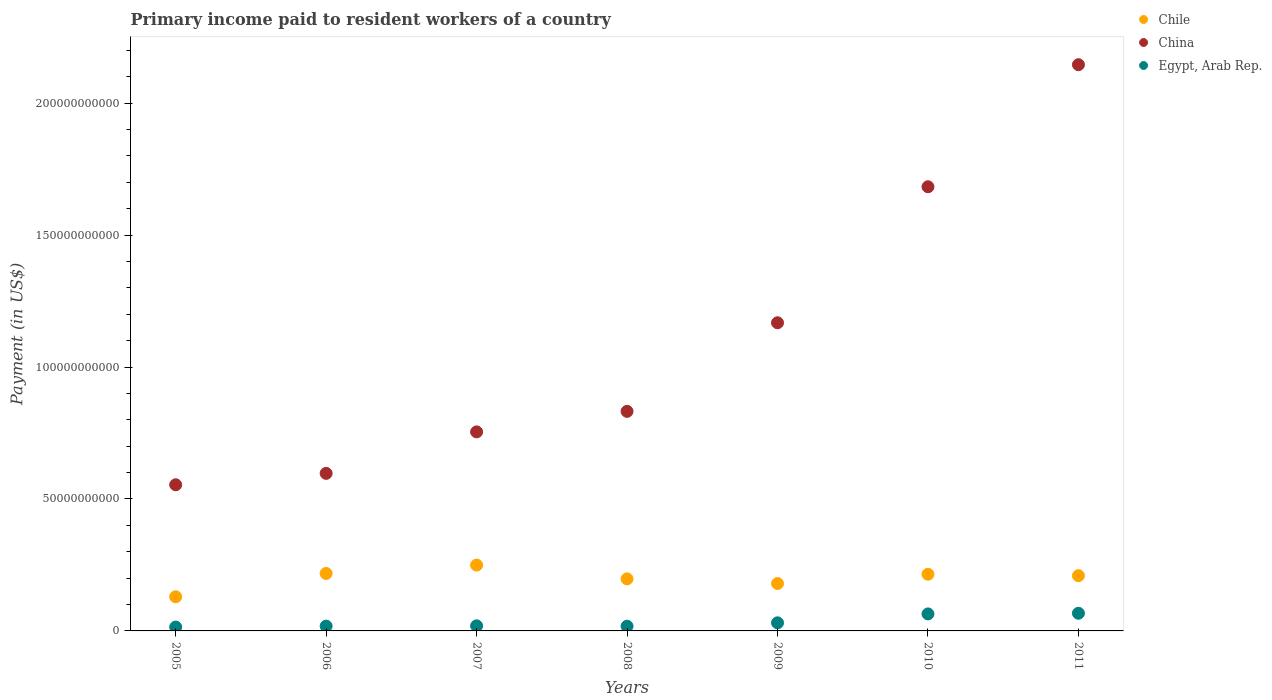Is the number of dotlines equal to the number of legend labels?
Offer a terse response. Yes. What is the amount paid to workers in Chile in 2006?
Keep it short and to the point. 2.18e+1. Across all years, what is the maximum amount paid to workers in Chile?
Provide a short and direct response. 2.49e+1. Across all years, what is the minimum amount paid to workers in China?
Your answer should be very brief. 5.54e+1. What is the total amount paid to workers in China in the graph?
Provide a succinct answer. 7.73e+11. What is the difference between the amount paid to workers in Egypt, Arab Rep. in 2005 and that in 2010?
Provide a succinct answer. -4.99e+09. What is the difference between the amount paid to workers in Egypt, Arab Rep. in 2009 and the amount paid to workers in Chile in 2007?
Keep it short and to the point. -2.19e+1. What is the average amount paid to workers in Chile per year?
Your answer should be compact. 2.00e+1. In the year 2008, what is the difference between the amount paid to workers in Chile and amount paid to workers in China?
Keep it short and to the point. -6.35e+1. In how many years, is the amount paid to workers in China greater than 150000000000 US$?
Offer a very short reply. 2. What is the ratio of the amount paid to workers in China in 2007 to that in 2010?
Your answer should be very brief. 0.45. Is the difference between the amount paid to workers in Chile in 2009 and 2010 greater than the difference between the amount paid to workers in China in 2009 and 2010?
Provide a short and direct response. Yes. What is the difference between the highest and the second highest amount paid to workers in Chile?
Your answer should be compact. 3.17e+09. What is the difference between the highest and the lowest amount paid to workers in Chile?
Your response must be concise. 1.20e+1. In how many years, is the amount paid to workers in China greater than the average amount paid to workers in China taken over all years?
Provide a short and direct response. 3. Is the sum of the amount paid to workers in Chile in 2008 and 2009 greater than the maximum amount paid to workers in Egypt, Arab Rep. across all years?
Your answer should be compact. Yes. What is the difference between two consecutive major ticks on the Y-axis?
Offer a terse response. 5.00e+1. Does the graph contain any zero values?
Provide a succinct answer. No. Where does the legend appear in the graph?
Your response must be concise. Top right. How many legend labels are there?
Provide a short and direct response. 3. How are the legend labels stacked?
Give a very brief answer. Vertical. What is the title of the graph?
Your answer should be very brief. Primary income paid to resident workers of a country. Does "Europe(all income levels)" appear as one of the legend labels in the graph?
Your answer should be compact. No. What is the label or title of the Y-axis?
Offer a terse response. Payment (in US$). What is the Payment (in US$) of Chile in 2005?
Provide a short and direct response. 1.29e+1. What is the Payment (in US$) in China in 2005?
Your answer should be compact. 5.54e+1. What is the Payment (in US$) of Egypt, Arab Rep. in 2005?
Ensure brevity in your answer.  1.46e+09. What is the Payment (in US$) of Chile in 2006?
Your answer should be compact. 2.18e+1. What is the Payment (in US$) of China in 2006?
Your answer should be very brief. 5.97e+1. What is the Payment (in US$) in Egypt, Arab Rep. in 2006?
Keep it short and to the point. 1.82e+09. What is the Payment (in US$) in Chile in 2007?
Your answer should be compact. 2.49e+1. What is the Payment (in US$) in China in 2007?
Provide a short and direct response. 7.54e+1. What is the Payment (in US$) in Egypt, Arab Rep. in 2007?
Provide a succinct answer. 1.92e+09. What is the Payment (in US$) in Chile in 2008?
Provide a succinct answer. 1.97e+1. What is the Payment (in US$) in China in 2008?
Your answer should be very brief. 8.32e+1. What is the Payment (in US$) of Egypt, Arab Rep. in 2008?
Your answer should be very brief. 1.78e+09. What is the Payment (in US$) in Chile in 2009?
Keep it short and to the point. 1.80e+1. What is the Payment (in US$) in China in 2009?
Make the answer very short. 1.17e+11. What is the Payment (in US$) of Egypt, Arab Rep. in 2009?
Provide a short and direct response. 3.07e+09. What is the Payment (in US$) in Chile in 2010?
Give a very brief answer. 2.15e+1. What is the Payment (in US$) of China in 2010?
Your answer should be compact. 1.68e+11. What is the Payment (in US$) in Egypt, Arab Rep. in 2010?
Provide a succinct answer. 6.45e+09. What is the Payment (in US$) in Chile in 2011?
Keep it short and to the point. 2.09e+1. What is the Payment (in US$) in China in 2011?
Offer a terse response. 2.15e+11. What is the Payment (in US$) of Egypt, Arab Rep. in 2011?
Keep it short and to the point. 6.69e+09. Across all years, what is the maximum Payment (in US$) in Chile?
Keep it short and to the point. 2.49e+1. Across all years, what is the maximum Payment (in US$) in China?
Offer a terse response. 2.15e+11. Across all years, what is the maximum Payment (in US$) in Egypt, Arab Rep.?
Provide a succinct answer. 6.69e+09. Across all years, what is the minimum Payment (in US$) of Chile?
Provide a short and direct response. 1.29e+1. Across all years, what is the minimum Payment (in US$) in China?
Your answer should be compact. 5.54e+1. Across all years, what is the minimum Payment (in US$) in Egypt, Arab Rep.?
Provide a succinct answer. 1.46e+09. What is the total Payment (in US$) in Chile in the graph?
Provide a succinct answer. 1.40e+11. What is the total Payment (in US$) of China in the graph?
Provide a succinct answer. 7.73e+11. What is the total Payment (in US$) in Egypt, Arab Rep. in the graph?
Your answer should be very brief. 2.32e+1. What is the difference between the Payment (in US$) in Chile in 2005 and that in 2006?
Your answer should be very brief. -8.84e+09. What is the difference between the Payment (in US$) of China in 2005 and that in 2006?
Offer a terse response. -4.32e+09. What is the difference between the Payment (in US$) in Egypt, Arab Rep. in 2005 and that in 2006?
Offer a very short reply. -3.62e+08. What is the difference between the Payment (in US$) in Chile in 2005 and that in 2007?
Make the answer very short. -1.20e+1. What is the difference between the Payment (in US$) in China in 2005 and that in 2007?
Provide a succinct answer. -2.00e+1. What is the difference between the Payment (in US$) in Egypt, Arab Rep. in 2005 and that in 2007?
Provide a short and direct response. -4.61e+08. What is the difference between the Payment (in US$) of Chile in 2005 and that in 2008?
Your answer should be very brief. -6.79e+09. What is the difference between the Payment (in US$) of China in 2005 and that in 2008?
Provide a succinct answer. -2.78e+1. What is the difference between the Payment (in US$) of Egypt, Arab Rep. in 2005 and that in 2008?
Make the answer very short. -3.16e+08. What is the difference between the Payment (in US$) of Chile in 2005 and that in 2009?
Offer a terse response. -5.03e+09. What is the difference between the Payment (in US$) in China in 2005 and that in 2009?
Your answer should be very brief. -6.14e+1. What is the difference between the Payment (in US$) of Egypt, Arab Rep. in 2005 and that in 2009?
Provide a succinct answer. -1.61e+09. What is the difference between the Payment (in US$) in Chile in 2005 and that in 2010?
Keep it short and to the point. -8.54e+09. What is the difference between the Payment (in US$) in China in 2005 and that in 2010?
Ensure brevity in your answer.  -1.13e+11. What is the difference between the Payment (in US$) of Egypt, Arab Rep. in 2005 and that in 2010?
Your answer should be very brief. -4.99e+09. What is the difference between the Payment (in US$) in Chile in 2005 and that in 2011?
Provide a succinct answer. -7.99e+09. What is the difference between the Payment (in US$) in China in 2005 and that in 2011?
Give a very brief answer. -1.59e+11. What is the difference between the Payment (in US$) in Egypt, Arab Rep. in 2005 and that in 2011?
Offer a terse response. -5.23e+09. What is the difference between the Payment (in US$) of Chile in 2006 and that in 2007?
Your response must be concise. -3.17e+09. What is the difference between the Payment (in US$) in China in 2006 and that in 2007?
Provide a succinct answer. -1.57e+1. What is the difference between the Payment (in US$) in Egypt, Arab Rep. in 2006 and that in 2007?
Offer a very short reply. -9.87e+07. What is the difference between the Payment (in US$) of Chile in 2006 and that in 2008?
Give a very brief answer. 2.05e+09. What is the difference between the Payment (in US$) of China in 2006 and that in 2008?
Your answer should be compact. -2.35e+1. What is the difference between the Payment (in US$) in Egypt, Arab Rep. in 2006 and that in 2008?
Your answer should be very brief. 4.58e+07. What is the difference between the Payment (in US$) of Chile in 2006 and that in 2009?
Your answer should be compact. 3.81e+09. What is the difference between the Payment (in US$) of China in 2006 and that in 2009?
Your response must be concise. -5.71e+1. What is the difference between the Payment (in US$) in Egypt, Arab Rep. in 2006 and that in 2009?
Your response must be concise. -1.25e+09. What is the difference between the Payment (in US$) of Chile in 2006 and that in 2010?
Keep it short and to the point. 2.93e+08. What is the difference between the Payment (in US$) of China in 2006 and that in 2010?
Offer a terse response. -1.09e+11. What is the difference between the Payment (in US$) in Egypt, Arab Rep. in 2006 and that in 2010?
Offer a very short reply. -4.62e+09. What is the difference between the Payment (in US$) in Chile in 2006 and that in 2011?
Provide a short and direct response. 8.47e+08. What is the difference between the Payment (in US$) in China in 2006 and that in 2011?
Ensure brevity in your answer.  -1.55e+11. What is the difference between the Payment (in US$) of Egypt, Arab Rep. in 2006 and that in 2011?
Keep it short and to the point. -4.87e+09. What is the difference between the Payment (in US$) of Chile in 2007 and that in 2008?
Make the answer very short. 5.22e+09. What is the difference between the Payment (in US$) of China in 2007 and that in 2008?
Keep it short and to the point. -7.78e+09. What is the difference between the Payment (in US$) in Egypt, Arab Rep. in 2007 and that in 2008?
Keep it short and to the point. 1.44e+08. What is the difference between the Payment (in US$) in Chile in 2007 and that in 2009?
Your response must be concise. 6.98e+09. What is the difference between the Payment (in US$) of China in 2007 and that in 2009?
Offer a very short reply. -4.14e+1. What is the difference between the Payment (in US$) in Egypt, Arab Rep. in 2007 and that in 2009?
Offer a very short reply. -1.15e+09. What is the difference between the Payment (in US$) in Chile in 2007 and that in 2010?
Provide a succinct answer. 3.47e+09. What is the difference between the Payment (in US$) in China in 2007 and that in 2010?
Offer a terse response. -9.29e+1. What is the difference between the Payment (in US$) of Egypt, Arab Rep. in 2007 and that in 2010?
Your answer should be very brief. -4.52e+09. What is the difference between the Payment (in US$) in Chile in 2007 and that in 2011?
Offer a terse response. 4.02e+09. What is the difference between the Payment (in US$) of China in 2007 and that in 2011?
Your answer should be very brief. -1.39e+11. What is the difference between the Payment (in US$) of Egypt, Arab Rep. in 2007 and that in 2011?
Your answer should be very brief. -4.77e+09. What is the difference between the Payment (in US$) in Chile in 2008 and that in 2009?
Give a very brief answer. 1.76e+09. What is the difference between the Payment (in US$) in China in 2008 and that in 2009?
Make the answer very short. -3.36e+1. What is the difference between the Payment (in US$) in Egypt, Arab Rep. in 2008 and that in 2009?
Offer a terse response. -1.29e+09. What is the difference between the Payment (in US$) in Chile in 2008 and that in 2010?
Ensure brevity in your answer.  -1.75e+09. What is the difference between the Payment (in US$) of China in 2008 and that in 2010?
Keep it short and to the point. -8.51e+1. What is the difference between the Payment (in US$) of Egypt, Arab Rep. in 2008 and that in 2010?
Your answer should be compact. -4.67e+09. What is the difference between the Payment (in US$) of Chile in 2008 and that in 2011?
Provide a short and direct response. -1.20e+09. What is the difference between the Payment (in US$) of China in 2008 and that in 2011?
Keep it short and to the point. -1.31e+11. What is the difference between the Payment (in US$) of Egypt, Arab Rep. in 2008 and that in 2011?
Provide a short and direct response. -4.92e+09. What is the difference between the Payment (in US$) in Chile in 2009 and that in 2010?
Keep it short and to the point. -3.52e+09. What is the difference between the Payment (in US$) of China in 2009 and that in 2010?
Keep it short and to the point. -5.15e+1. What is the difference between the Payment (in US$) of Egypt, Arab Rep. in 2009 and that in 2010?
Provide a succinct answer. -3.38e+09. What is the difference between the Payment (in US$) of Chile in 2009 and that in 2011?
Make the answer very short. -2.96e+09. What is the difference between the Payment (in US$) of China in 2009 and that in 2011?
Your response must be concise. -9.78e+1. What is the difference between the Payment (in US$) of Egypt, Arab Rep. in 2009 and that in 2011?
Provide a short and direct response. -3.63e+09. What is the difference between the Payment (in US$) in Chile in 2010 and that in 2011?
Offer a terse response. 5.54e+08. What is the difference between the Payment (in US$) in China in 2010 and that in 2011?
Make the answer very short. -4.63e+1. What is the difference between the Payment (in US$) of Egypt, Arab Rep. in 2010 and that in 2011?
Offer a very short reply. -2.49e+08. What is the difference between the Payment (in US$) of Chile in 2005 and the Payment (in US$) of China in 2006?
Offer a very short reply. -4.68e+1. What is the difference between the Payment (in US$) in Chile in 2005 and the Payment (in US$) in Egypt, Arab Rep. in 2006?
Your answer should be compact. 1.11e+1. What is the difference between the Payment (in US$) in China in 2005 and the Payment (in US$) in Egypt, Arab Rep. in 2006?
Ensure brevity in your answer.  5.36e+1. What is the difference between the Payment (in US$) of Chile in 2005 and the Payment (in US$) of China in 2007?
Offer a very short reply. -6.25e+1. What is the difference between the Payment (in US$) in Chile in 2005 and the Payment (in US$) in Egypt, Arab Rep. in 2007?
Provide a succinct answer. 1.10e+1. What is the difference between the Payment (in US$) in China in 2005 and the Payment (in US$) in Egypt, Arab Rep. in 2007?
Keep it short and to the point. 5.35e+1. What is the difference between the Payment (in US$) in Chile in 2005 and the Payment (in US$) in China in 2008?
Your response must be concise. -7.03e+1. What is the difference between the Payment (in US$) in Chile in 2005 and the Payment (in US$) in Egypt, Arab Rep. in 2008?
Provide a succinct answer. 1.12e+1. What is the difference between the Payment (in US$) of China in 2005 and the Payment (in US$) of Egypt, Arab Rep. in 2008?
Keep it short and to the point. 5.36e+1. What is the difference between the Payment (in US$) in Chile in 2005 and the Payment (in US$) in China in 2009?
Offer a terse response. -1.04e+11. What is the difference between the Payment (in US$) in Chile in 2005 and the Payment (in US$) in Egypt, Arab Rep. in 2009?
Your response must be concise. 9.87e+09. What is the difference between the Payment (in US$) in China in 2005 and the Payment (in US$) in Egypt, Arab Rep. in 2009?
Provide a short and direct response. 5.23e+1. What is the difference between the Payment (in US$) in Chile in 2005 and the Payment (in US$) in China in 2010?
Give a very brief answer. -1.55e+11. What is the difference between the Payment (in US$) of Chile in 2005 and the Payment (in US$) of Egypt, Arab Rep. in 2010?
Provide a succinct answer. 6.49e+09. What is the difference between the Payment (in US$) in China in 2005 and the Payment (in US$) in Egypt, Arab Rep. in 2010?
Ensure brevity in your answer.  4.89e+1. What is the difference between the Payment (in US$) of Chile in 2005 and the Payment (in US$) of China in 2011?
Your answer should be very brief. -2.02e+11. What is the difference between the Payment (in US$) in Chile in 2005 and the Payment (in US$) in Egypt, Arab Rep. in 2011?
Ensure brevity in your answer.  6.24e+09. What is the difference between the Payment (in US$) in China in 2005 and the Payment (in US$) in Egypt, Arab Rep. in 2011?
Your response must be concise. 4.87e+1. What is the difference between the Payment (in US$) of Chile in 2006 and the Payment (in US$) of China in 2007?
Your answer should be very brief. -5.37e+1. What is the difference between the Payment (in US$) in Chile in 2006 and the Payment (in US$) in Egypt, Arab Rep. in 2007?
Your response must be concise. 1.99e+1. What is the difference between the Payment (in US$) in China in 2006 and the Payment (in US$) in Egypt, Arab Rep. in 2007?
Your answer should be compact. 5.78e+1. What is the difference between the Payment (in US$) in Chile in 2006 and the Payment (in US$) in China in 2008?
Your answer should be very brief. -6.14e+1. What is the difference between the Payment (in US$) of Chile in 2006 and the Payment (in US$) of Egypt, Arab Rep. in 2008?
Your answer should be compact. 2.00e+1. What is the difference between the Payment (in US$) of China in 2006 and the Payment (in US$) of Egypt, Arab Rep. in 2008?
Keep it short and to the point. 5.79e+1. What is the difference between the Payment (in US$) of Chile in 2006 and the Payment (in US$) of China in 2009?
Ensure brevity in your answer.  -9.50e+1. What is the difference between the Payment (in US$) of Chile in 2006 and the Payment (in US$) of Egypt, Arab Rep. in 2009?
Offer a terse response. 1.87e+1. What is the difference between the Payment (in US$) of China in 2006 and the Payment (in US$) of Egypt, Arab Rep. in 2009?
Provide a succinct answer. 5.66e+1. What is the difference between the Payment (in US$) in Chile in 2006 and the Payment (in US$) in China in 2010?
Make the answer very short. -1.47e+11. What is the difference between the Payment (in US$) in Chile in 2006 and the Payment (in US$) in Egypt, Arab Rep. in 2010?
Make the answer very short. 1.53e+1. What is the difference between the Payment (in US$) in China in 2006 and the Payment (in US$) in Egypt, Arab Rep. in 2010?
Offer a very short reply. 5.33e+1. What is the difference between the Payment (in US$) in Chile in 2006 and the Payment (in US$) in China in 2011?
Provide a succinct answer. -1.93e+11. What is the difference between the Payment (in US$) in Chile in 2006 and the Payment (in US$) in Egypt, Arab Rep. in 2011?
Give a very brief answer. 1.51e+1. What is the difference between the Payment (in US$) of China in 2006 and the Payment (in US$) of Egypt, Arab Rep. in 2011?
Ensure brevity in your answer.  5.30e+1. What is the difference between the Payment (in US$) of Chile in 2007 and the Payment (in US$) of China in 2008?
Offer a terse response. -5.83e+1. What is the difference between the Payment (in US$) in Chile in 2007 and the Payment (in US$) in Egypt, Arab Rep. in 2008?
Ensure brevity in your answer.  2.32e+1. What is the difference between the Payment (in US$) of China in 2007 and the Payment (in US$) of Egypt, Arab Rep. in 2008?
Ensure brevity in your answer.  7.37e+1. What is the difference between the Payment (in US$) in Chile in 2007 and the Payment (in US$) in China in 2009?
Ensure brevity in your answer.  -9.18e+1. What is the difference between the Payment (in US$) of Chile in 2007 and the Payment (in US$) of Egypt, Arab Rep. in 2009?
Your response must be concise. 2.19e+1. What is the difference between the Payment (in US$) of China in 2007 and the Payment (in US$) of Egypt, Arab Rep. in 2009?
Your answer should be compact. 7.24e+1. What is the difference between the Payment (in US$) in Chile in 2007 and the Payment (in US$) in China in 2010?
Give a very brief answer. -1.43e+11. What is the difference between the Payment (in US$) in Chile in 2007 and the Payment (in US$) in Egypt, Arab Rep. in 2010?
Make the answer very short. 1.85e+1. What is the difference between the Payment (in US$) in China in 2007 and the Payment (in US$) in Egypt, Arab Rep. in 2010?
Offer a very short reply. 6.90e+1. What is the difference between the Payment (in US$) of Chile in 2007 and the Payment (in US$) of China in 2011?
Keep it short and to the point. -1.90e+11. What is the difference between the Payment (in US$) in Chile in 2007 and the Payment (in US$) in Egypt, Arab Rep. in 2011?
Your answer should be compact. 1.83e+1. What is the difference between the Payment (in US$) in China in 2007 and the Payment (in US$) in Egypt, Arab Rep. in 2011?
Offer a terse response. 6.87e+1. What is the difference between the Payment (in US$) in Chile in 2008 and the Payment (in US$) in China in 2009?
Make the answer very short. -9.71e+1. What is the difference between the Payment (in US$) in Chile in 2008 and the Payment (in US$) in Egypt, Arab Rep. in 2009?
Keep it short and to the point. 1.67e+1. What is the difference between the Payment (in US$) in China in 2008 and the Payment (in US$) in Egypt, Arab Rep. in 2009?
Your answer should be very brief. 8.01e+1. What is the difference between the Payment (in US$) in Chile in 2008 and the Payment (in US$) in China in 2010?
Your answer should be compact. -1.49e+11. What is the difference between the Payment (in US$) in Chile in 2008 and the Payment (in US$) in Egypt, Arab Rep. in 2010?
Ensure brevity in your answer.  1.33e+1. What is the difference between the Payment (in US$) of China in 2008 and the Payment (in US$) of Egypt, Arab Rep. in 2010?
Keep it short and to the point. 7.68e+1. What is the difference between the Payment (in US$) of Chile in 2008 and the Payment (in US$) of China in 2011?
Ensure brevity in your answer.  -1.95e+11. What is the difference between the Payment (in US$) in Chile in 2008 and the Payment (in US$) in Egypt, Arab Rep. in 2011?
Your answer should be compact. 1.30e+1. What is the difference between the Payment (in US$) in China in 2008 and the Payment (in US$) in Egypt, Arab Rep. in 2011?
Your response must be concise. 7.65e+1. What is the difference between the Payment (in US$) of Chile in 2009 and the Payment (in US$) of China in 2010?
Provide a succinct answer. -1.50e+11. What is the difference between the Payment (in US$) of Chile in 2009 and the Payment (in US$) of Egypt, Arab Rep. in 2010?
Make the answer very short. 1.15e+1. What is the difference between the Payment (in US$) of China in 2009 and the Payment (in US$) of Egypt, Arab Rep. in 2010?
Ensure brevity in your answer.  1.10e+11. What is the difference between the Payment (in US$) of Chile in 2009 and the Payment (in US$) of China in 2011?
Provide a short and direct response. -1.97e+11. What is the difference between the Payment (in US$) of Chile in 2009 and the Payment (in US$) of Egypt, Arab Rep. in 2011?
Provide a succinct answer. 1.13e+1. What is the difference between the Payment (in US$) of China in 2009 and the Payment (in US$) of Egypt, Arab Rep. in 2011?
Provide a short and direct response. 1.10e+11. What is the difference between the Payment (in US$) of Chile in 2010 and the Payment (in US$) of China in 2011?
Provide a short and direct response. -1.93e+11. What is the difference between the Payment (in US$) of Chile in 2010 and the Payment (in US$) of Egypt, Arab Rep. in 2011?
Your answer should be very brief. 1.48e+1. What is the difference between the Payment (in US$) in China in 2010 and the Payment (in US$) in Egypt, Arab Rep. in 2011?
Offer a very short reply. 1.62e+11. What is the average Payment (in US$) in Chile per year?
Ensure brevity in your answer.  2.00e+1. What is the average Payment (in US$) in China per year?
Your answer should be compact. 1.10e+11. What is the average Payment (in US$) of Egypt, Arab Rep. per year?
Offer a very short reply. 3.31e+09. In the year 2005, what is the difference between the Payment (in US$) of Chile and Payment (in US$) of China?
Your response must be concise. -4.24e+1. In the year 2005, what is the difference between the Payment (in US$) of Chile and Payment (in US$) of Egypt, Arab Rep.?
Provide a short and direct response. 1.15e+1. In the year 2005, what is the difference between the Payment (in US$) of China and Payment (in US$) of Egypt, Arab Rep.?
Provide a succinct answer. 5.39e+1. In the year 2006, what is the difference between the Payment (in US$) in Chile and Payment (in US$) in China?
Offer a very short reply. -3.79e+1. In the year 2006, what is the difference between the Payment (in US$) in Chile and Payment (in US$) in Egypt, Arab Rep.?
Make the answer very short. 2.00e+1. In the year 2006, what is the difference between the Payment (in US$) of China and Payment (in US$) of Egypt, Arab Rep.?
Ensure brevity in your answer.  5.79e+1. In the year 2007, what is the difference between the Payment (in US$) of Chile and Payment (in US$) of China?
Make the answer very short. -5.05e+1. In the year 2007, what is the difference between the Payment (in US$) in Chile and Payment (in US$) in Egypt, Arab Rep.?
Provide a short and direct response. 2.30e+1. In the year 2007, what is the difference between the Payment (in US$) in China and Payment (in US$) in Egypt, Arab Rep.?
Give a very brief answer. 7.35e+1. In the year 2008, what is the difference between the Payment (in US$) in Chile and Payment (in US$) in China?
Ensure brevity in your answer.  -6.35e+1. In the year 2008, what is the difference between the Payment (in US$) in Chile and Payment (in US$) in Egypt, Arab Rep.?
Provide a short and direct response. 1.80e+1. In the year 2008, what is the difference between the Payment (in US$) of China and Payment (in US$) of Egypt, Arab Rep.?
Provide a short and direct response. 8.14e+1. In the year 2009, what is the difference between the Payment (in US$) of Chile and Payment (in US$) of China?
Offer a very short reply. -9.88e+1. In the year 2009, what is the difference between the Payment (in US$) in Chile and Payment (in US$) in Egypt, Arab Rep.?
Provide a short and direct response. 1.49e+1. In the year 2009, what is the difference between the Payment (in US$) in China and Payment (in US$) in Egypt, Arab Rep.?
Give a very brief answer. 1.14e+11. In the year 2010, what is the difference between the Payment (in US$) in Chile and Payment (in US$) in China?
Your answer should be compact. -1.47e+11. In the year 2010, what is the difference between the Payment (in US$) of Chile and Payment (in US$) of Egypt, Arab Rep.?
Offer a very short reply. 1.50e+1. In the year 2010, what is the difference between the Payment (in US$) of China and Payment (in US$) of Egypt, Arab Rep.?
Make the answer very short. 1.62e+11. In the year 2011, what is the difference between the Payment (in US$) of Chile and Payment (in US$) of China?
Offer a very short reply. -1.94e+11. In the year 2011, what is the difference between the Payment (in US$) in Chile and Payment (in US$) in Egypt, Arab Rep.?
Your response must be concise. 1.42e+1. In the year 2011, what is the difference between the Payment (in US$) in China and Payment (in US$) in Egypt, Arab Rep.?
Offer a very short reply. 2.08e+11. What is the ratio of the Payment (in US$) of Chile in 2005 to that in 2006?
Your response must be concise. 0.59. What is the ratio of the Payment (in US$) in China in 2005 to that in 2006?
Your answer should be compact. 0.93. What is the ratio of the Payment (in US$) in Egypt, Arab Rep. in 2005 to that in 2006?
Offer a very short reply. 0.8. What is the ratio of the Payment (in US$) of Chile in 2005 to that in 2007?
Ensure brevity in your answer.  0.52. What is the ratio of the Payment (in US$) of China in 2005 to that in 2007?
Provide a short and direct response. 0.73. What is the ratio of the Payment (in US$) of Egypt, Arab Rep. in 2005 to that in 2007?
Offer a very short reply. 0.76. What is the ratio of the Payment (in US$) in Chile in 2005 to that in 2008?
Your answer should be very brief. 0.66. What is the ratio of the Payment (in US$) of China in 2005 to that in 2008?
Give a very brief answer. 0.67. What is the ratio of the Payment (in US$) of Egypt, Arab Rep. in 2005 to that in 2008?
Provide a short and direct response. 0.82. What is the ratio of the Payment (in US$) in Chile in 2005 to that in 2009?
Provide a short and direct response. 0.72. What is the ratio of the Payment (in US$) of China in 2005 to that in 2009?
Provide a short and direct response. 0.47. What is the ratio of the Payment (in US$) of Egypt, Arab Rep. in 2005 to that in 2009?
Offer a terse response. 0.48. What is the ratio of the Payment (in US$) of Chile in 2005 to that in 2010?
Your answer should be very brief. 0.6. What is the ratio of the Payment (in US$) in China in 2005 to that in 2010?
Make the answer very short. 0.33. What is the ratio of the Payment (in US$) of Egypt, Arab Rep. in 2005 to that in 2010?
Give a very brief answer. 0.23. What is the ratio of the Payment (in US$) in Chile in 2005 to that in 2011?
Your response must be concise. 0.62. What is the ratio of the Payment (in US$) in China in 2005 to that in 2011?
Offer a very short reply. 0.26. What is the ratio of the Payment (in US$) in Egypt, Arab Rep. in 2005 to that in 2011?
Provide a succinct answer. 0.22. What is the ratio of the Payment (in US$) in Chile in 2006 to that in 2007?
Make the answer very short. 0.87. What is the ratio of the Payment (in US$) in China in 2006 to that in 2007?
Provide a succinct answer. 0.79. What is the ratio of the Payment (in US$) in Egypt, Arab Rep. in 2006 to that in 2007?
Offer a terse response. 0.95. What is the ratio of the Payment (in US$) of Chile in 2006 to that in 2008?
Your response must be concise. 1.1. What is the ratio of the Payment (in US$) of China in 2006 to that in 2008?
Your answer should be very brief. 0.72. What is the ratio of the Payment (in US$) of Egypt, Arab Rep. in 2006 to that in 2008?
Your answer should be very brief. 1.03. What is the ratio of the Payment (in US$) in Chile in 2006 to that in 2009?
Your response must be concise. 1.21. What is the ratio of the Payment (in US$) of China in 2006 to that in 2009?
Give a very brief answer. 0.51. What is the ratio of the Payment (in US$) of Egypt, Arab Rep. in 2006 to that in 2009?
Offer a terse response. 0.59. What is the ratio of the Payment (in US$) in Chile in 2006 to that in 2010?
Keep it short and to the point. 1.01. What is the ratio of the Payment (in US$) in China in 2006 to that in 2010?
Ensure brevity in your answer.  0.35. What is the ratio of the Payment (in US$) in Egypt, Arab Rep. in 2006 to that in 2010?
Your response must be concise. 0.28. What is the ratio of the Payment (in US$) of Chile in 2006 to that in 2011?
Ensure brevity in your answer.  1.04. What is the ratio of the Payment (in US$) of China in 2006 to that in 2011?
Your answer should be very brief. 0.28. What is the ratio of the Payment (in US$) of Egypt, Arab Rep. in 2006 to that in 2011?
Ensure brevity in your answer.  0.27. What is the ratio of the Payment (in US$) in Chile in 2007 to that in 2008?
Keep it short and to the point. 1.26. What is the ratio of the Payment (in US$) of China in 2007 to that in 2008?
Your answer should be very brief. 0.91. What is the ratio of the Payment (in US$) of Egypt, Arab Rep. in 2007 to that in 2008?
Your answer should be very brief. 1.08. What is the ratio of the Payment (in US$) of Chile in 2007 to that in 2009?
Offer a terse response. 1.39. What is the ratio of the Payment (in US$) in China in 2007 to that in 2009?
Offer a terse response. 0.65. What is the ratio of the Payment (in US$) in Egypt, Arab Rep. in 2007 to that in 2009?
Give a very brief answer. 0.63. What is the ratio of the Payment (in US$) in Chile in 2007 to that in 2010?
Ensure brevity in your answer.  1.16. What is the ratio of the Payment (in US$) of China in 2007 to that in 2010?
Your answer should be compact. 0.45. What is the ratio of the Payment (in US$) of Egypt, Arab Rep. in 2007 to that in 2010?
Make the answer very short. 0.3. What is the ratio of the Payment (in US$) of Chile in 2007 to that in 2011?
Your answer should be compact. 1.19. What is the ratio of the Payment (in US$) of China in 2007 to that in 2011?
Ensure brevity in your answer.  0.35. What is the ratio of the Payment (in US$) in Egypt, Arab Rep. in 2007 to that in 2011?
Offer a terse response. 0.29. What is the ratio of the Payment (in US$) in Chile in 2008 to that in 2009?
Your answer should be very brief. 1.1. What is the ratio of the Payment (in US$) in China in 2008 to that in 2009?
Keep it short and to the point. 0.71. What is the ratio of the Payment (in US$) of Egypt, Arab Rep. in 2008 to that in 2009?
Your response must be concise. 0.58. What is the ratio of the Payment (in US$) of Chile in 2008 to that in 2010?
Your response must be concise. 0.92. What is the ratio of the Payment (in US$) in China in 2008 to that in 2010?
Offer a terse response. 0.49. What is the ratio of the Payment (in US$) in Egypt, Arab Rep. in 2008 to that in 2010?
Your response must be concise. 0.28. What is the ratio of the Payment (in US$) in Chile in 2008 to that in 2011?
Provide a succinct answer. 0.94. What is the ratio of the Payment (in US$) in China in 2008 to that in 2011?
Your response must be concise. 0.39. What is the ratio of the Payment (in US$) of Egypt, Arab Rep. in 2008 to that in 2011?
Your answer should be compact. 0.27. What is the ratio of the Payment (in US$) in Chile in 2009 to that in 2010?
Make the answer very short. 0.84. What is the ratio of the Payment (in US$) in China in 2009 to that in 2010?
Offer a very short reply. 0.69. What is the ratio of the Payment (in US$) in Egypt, Arab Rep. in 2009 to that in 2010?
Give a very brief answer. 0.48. What is the ratio of the Payment (in US$) in Chile in 2009 to that in 2011?
Keep it short and to the point. 0.86. What is the ratio of the Payment (in US$) in China in 2009 to that in 2011?
Your answer should be compact. 0.54. What is the ratio of the Payment (in US$) of Egypt, Arab Rep. in 2009 to that in 2011?
Provide a succinct answer. 0.46. What is the ratio of the Payment (in US$) of Chile in 2010 to that in 2011?
Ensure brevity in your answer.  1.03. What is the ratio of the Payment (in US$) of China in 2010 to that in 2011?
Give a very brief answer. 0.78. What is the ratio of the Payment (in US$) in Egypt, Arab Rep. in 2010 to that in 2011?
Make the answer very short. 0.96. What is the difference between the highest and the second highest Payment (in US$) of Chile?
Your response must be concise. 3.17e+09. What is the difference between the highest and the second highest Payment (in US$) in China?
Provide a short and direct response. 4.63e+1. What is the difference between the highest and the second highest Payment (in US$) of Egypt, Arab Rep.?
Offer a very short reply. 2.49e+08. What is the difference between the highest and the lowest Payment (in US$) of Chile?
Make the answer very short. 1.20e+1. What is the difference between the highest and the lowest Payment (in US$) in China?
Your response must be concise. 1.59e+11. What is the difference between the highest and the lowest Payment (in US$) of Egypt, Arab Rep.?
Make the answer very short. 5.23e+09. 